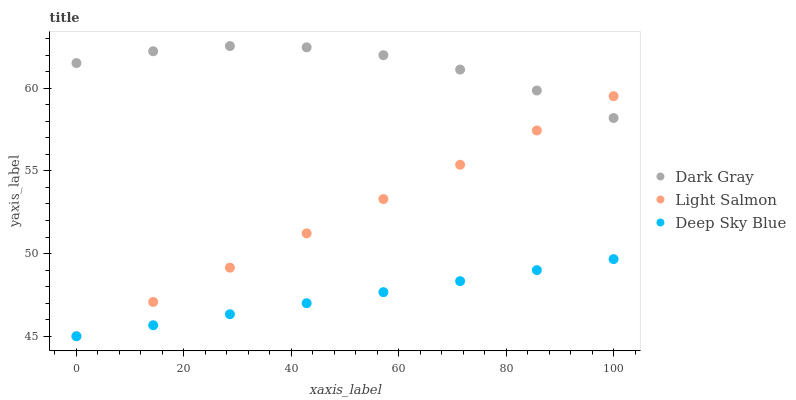Does Deep Sky Blue have the minimum area under the curve?
Answer yes or no. Yes. Does Dark Gray have the maximum area under the curve?
Answer yes or no. Yes. Does Light Salmon have the minimum area under the curve?
Answer yes or no. No. Does Light Salmon have the maximum area under the curve?
Answer yes or no. No. Is Light Salmon the smoothest?
Answer yes or no. Yes. Is Dark Gray the roughest?
Answer yes or no. Yes. Is Deep Sky Blue the smoothest?
Answer yes or no. No. Is Deep Sky Blue the roughest?
Answer yes or no. No. Does Light Salmon have the lowest value?
Answer yes or no. Yes. Does Dark Gray have the highest value?
Answer yes or no. Yes. Does Light Salmon have the highest value?
Answer yes or no. No. Is Deep Sky Blue less than Dark Gray?
Answer yes or no. Yes. Is Dark Gray greater than Deep Sky Blue?
Answer yes or no. Yes. Does Deep Sky Blue intersect Light Salmon?
Answer yes or no. Yes. Is Deep Sky Blue less than Light Salmon?
Answer yes or no. No. Is Deep Sky Blue greater than Light Salmon?
Answer yes or no. No. Does Deep Sky Blue intersect Dark Gray?
Answer yes or no. No. 